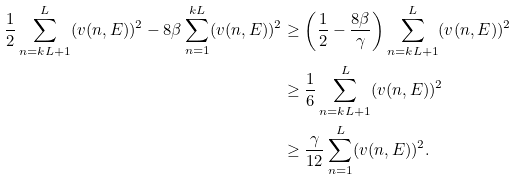<formula> <loc_0><loc_0><loc_500><loc_500>\frac { 1 } { 2 } \sum _ { n = k L + 1 } ^ { L } ( v ( n , E ) ) ^ { 2 } - 8 \beta \sum _ { n = 1 } ^ { k L } ( v ( n , E ) ) ^ { 2 } & \geq \left ( \frac { 1 } { 2 } - \frac { 8 \beta } { \gamma } \right ) \sum _ { n = k L + 1 } ^ { L } ( v ( n , E ) ) ^ { 2 } \\ & \geq \frac { 1 } { 6 } \sum _ { n = k L + 1 } ^ { L } ( v ( n , E ) ) ^ { 2 } \\ & \geq \frac { \gamma } { 1 2 } \sum _ { n = 1 } ^ { L } ( v ( n , E ) ) ^ { 2 } .</formula> 